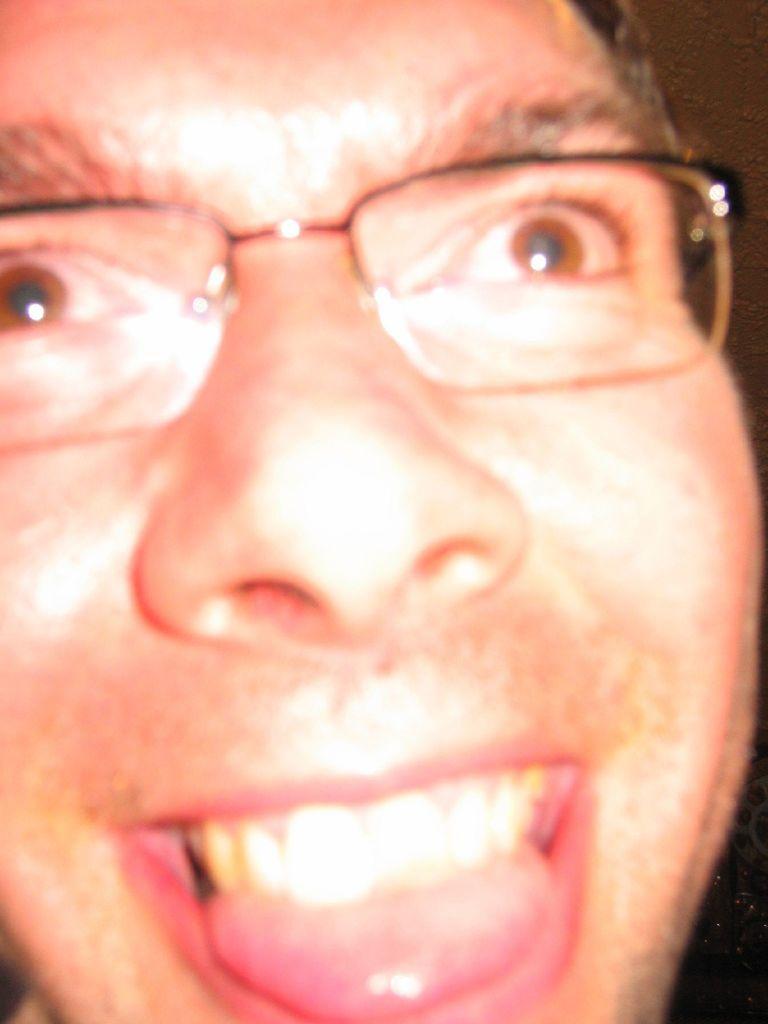How would you summarize this image in a sentence or two? In the image there is a person showing tongue, he is wearing glasses. 